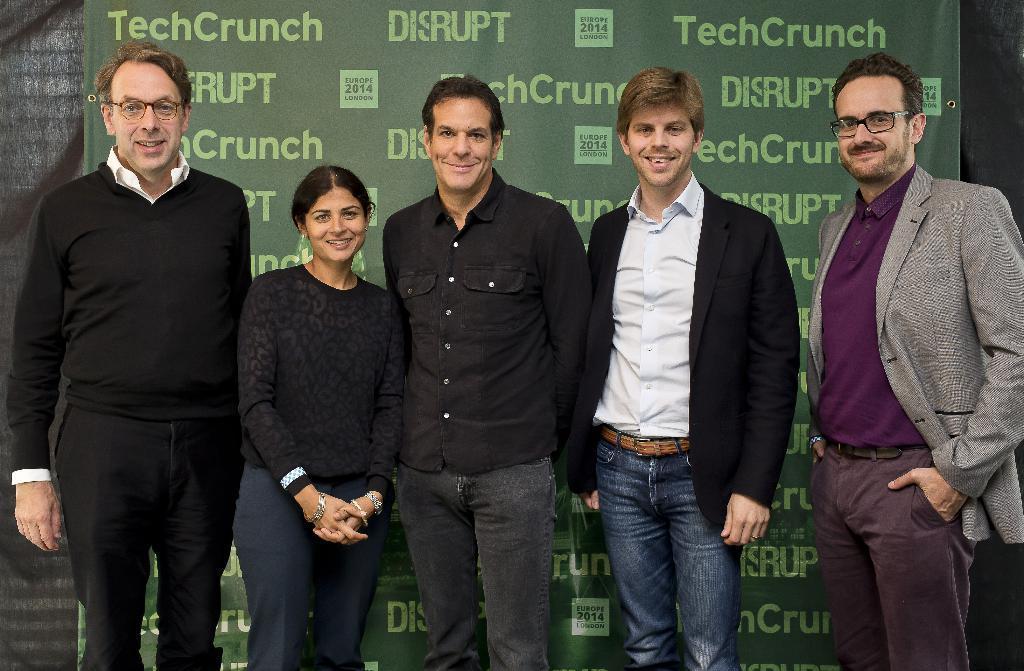In one or two sentences, can you explain what this image depicts? in the foreground of the picture we can see group of people standing. In the background we can see a banner and curtain. 